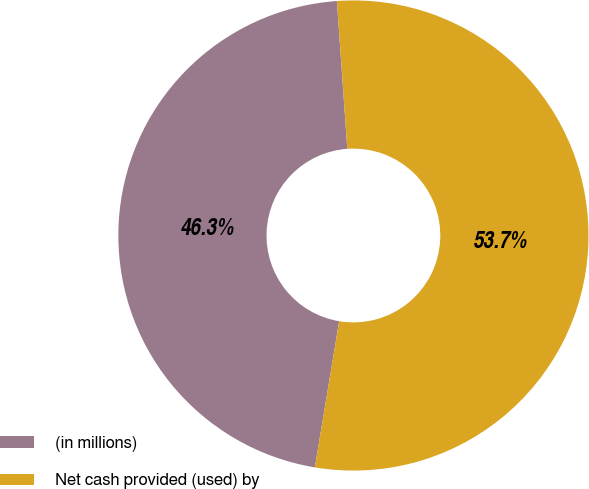Convert chart. <chart><loc_0><loc_0><loc_500><loc_500><pie_chart><fcel>(in millions)<fcel>Net cash provided (used) by<nl><fcel>46.26%<fcel>53.74%<nl></chart> 